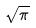Convert formula to latex. <formula><loc_0><loc_0><loc_500><loc_500>\sqrt { \pi }</formula> 